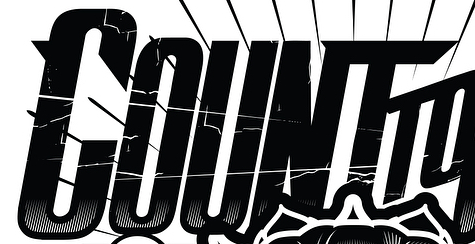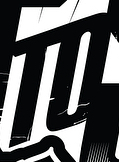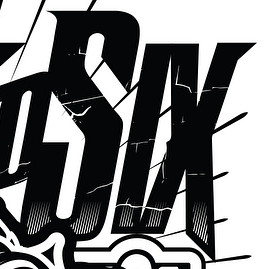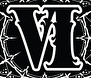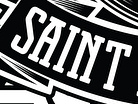Read the text from these images in sequence, separated by a semicolon. COUNT; TO; SIX; VI; SAINT 